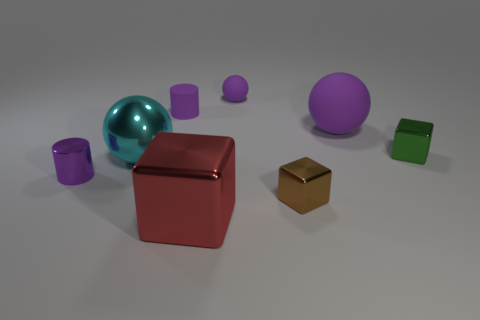Subtract all cylinders. How many objects are left? 6 Add 2 purple matte cylinders. How many objects exist? 10 Subtract all large purple objects. Subtract all small purple rubber cylinders. How many objects are left? 6 Add 5 brown things. How many brown things are left? 6 Add 2 big blue objects. How many big blue objects exist? 2 Subtract 0 blue cylinders. How many objects are left? 8 